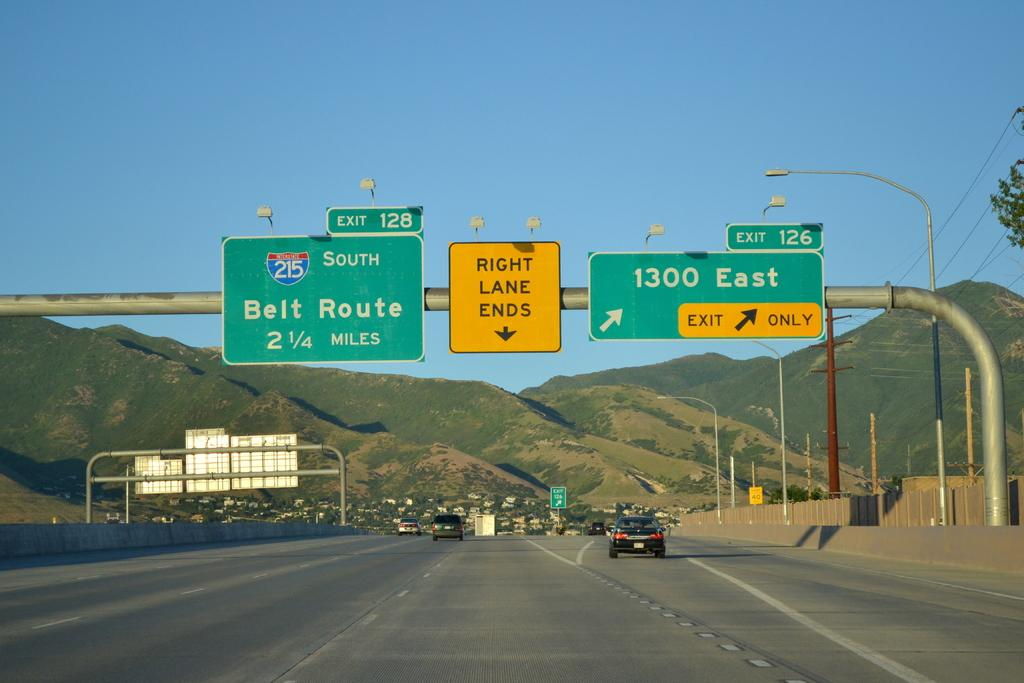<image>
Render a clear and concise summary of the photo. Highway 215 heading south, with 1300 East off to the right. 